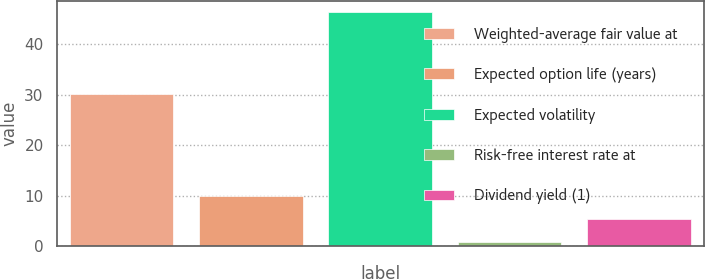Convert chart to OTSL. <chart><loc_0><loc_0><loc_500><loc_500><bar_chart><fcel>Weighted-average fair value at<fcel>Expected option life (years)<fcel>Expected volatility<fcel>Risk-free interest rate at<fcel>Dividend yield (1)<nl><fcel>30.15<fcel>9.9<fcel>46.3<fcel>0.8<fcel>5.35<nl></chart> 